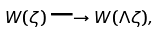Convert formula to latex. <formula><loc_0><loc_0><loc_500><loc_500>W ( \zeta ) \longrightarrow W ( \Lambda \zeta ) ,</formula> 